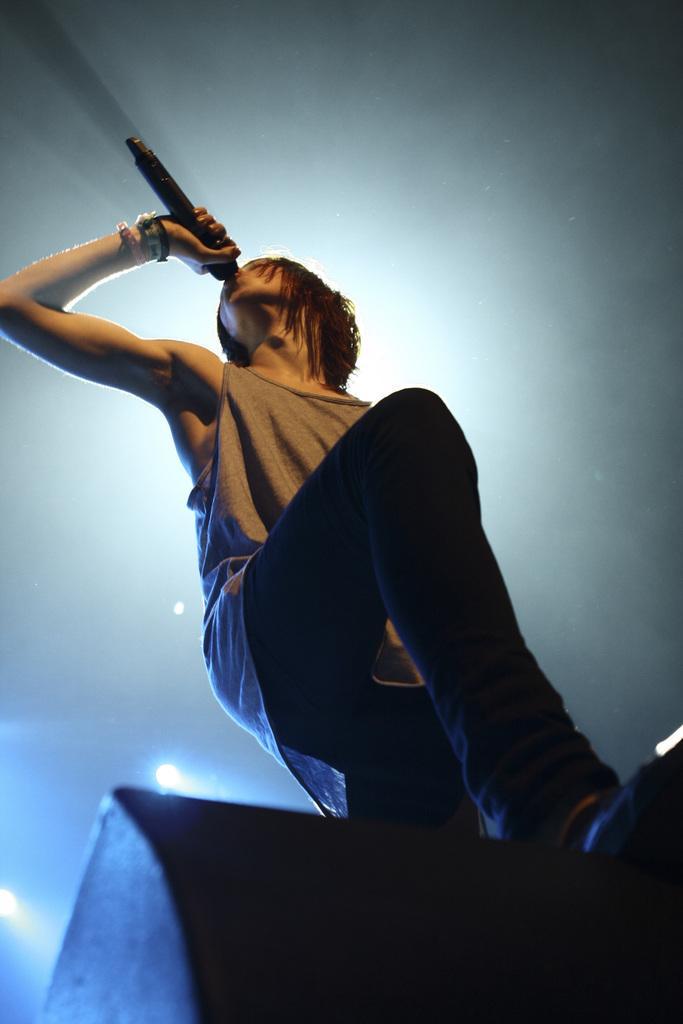How would you summarize this image in a sentence or two? In this picture we can observe a person standing and holding a mic in his hand. He is wearing a brown color T shirt. In the background we can observe lights which are in white and blue color. 